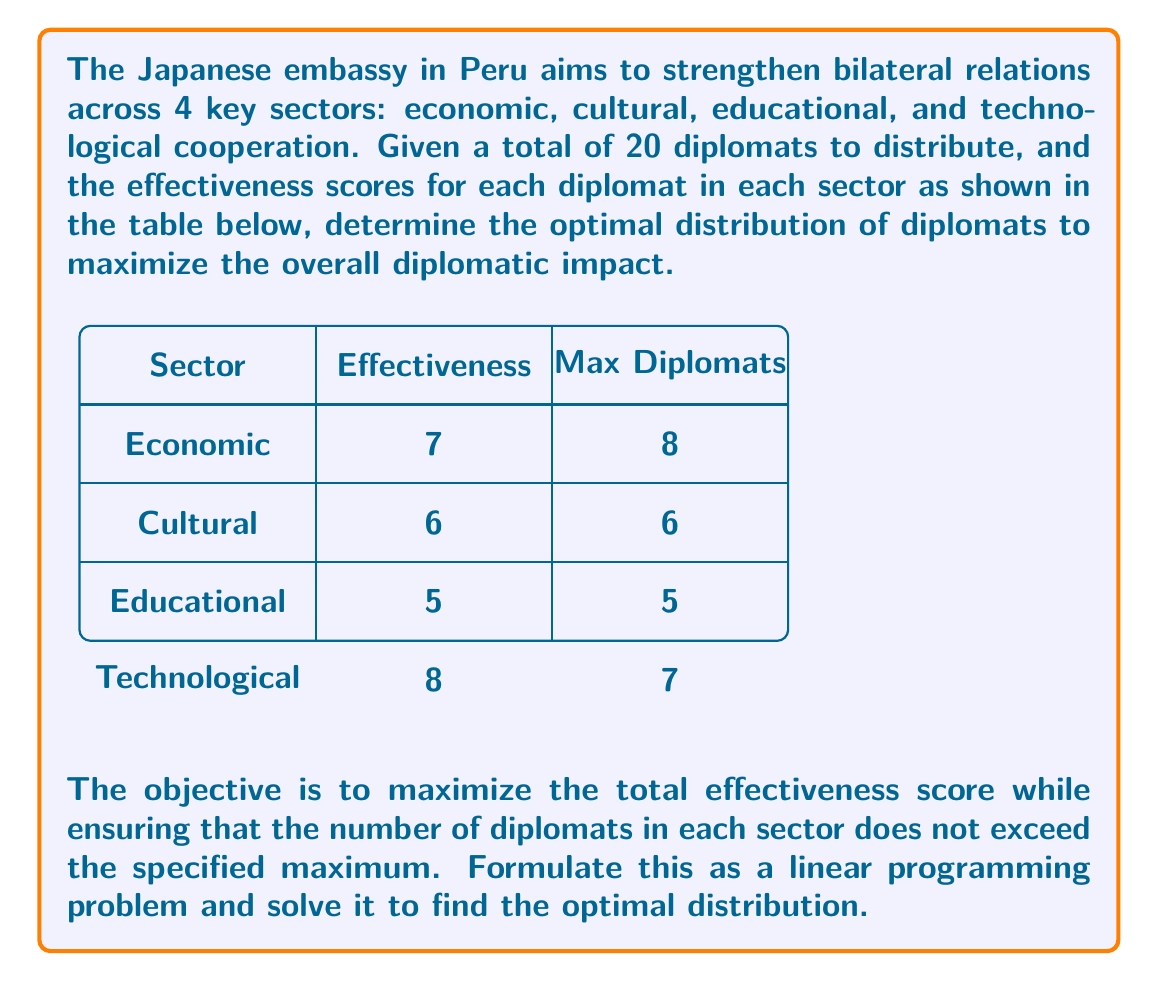What is the answer to this math problem? Let's approach this step-by-step:

1) Define variables:
   Let $x_1, x_2, x_3, x_4$ represent the number of diplomats assigned to economic, cultural, educational, and technological sectors respectively.

2) Objective function:
   Maximize $Z = 7x_1 + 6x_2 + 5x_3 + 8x_4$

3) Constraints:
   a) Total diplomats: $x_1 + x_2 + x_3 + x_4 \leq 20$
   b) Sector limits: $x_1 \leq 8, x_2 \leq 6, x_3 \leq 5, x_4 \leq 7$
   c) Non-negativity: $x_1, x_2, x_3, x_4 \geq 0$

4) This is a linear programming problem. We can solve it using the simplex method or a graphical method. In this case, we'll use a greedy approach due to the nature of the problem:

   - Start with the sector with the highest effectiveness (Technological: 8)
   - Assign the maximum allowed diplomats (7)
   - Move to the next highest effectiveness sector (Economic: 7)
   - Assign the remaining diplomats (13) up to the maximum allowed (8)
   - Continue this process

5) Distribution:
   Technological: 7 diplomats
   Economic: 8 diplomats
   Cultural: 5 diplomats (remaining diplomats)
   Educational: 0 diplomats

6) Check constraints:
   Total diplomats used: 7 + 8 + 5 + 0 = 20 (satisfies total constraint)
   All sector limits are respected

7) Calculate total effectiveness:
   $Z = 7(8) + 6(5) + 5(0) + 8(7) = 56 + 30 + 0 + 56 = 142$

Therefore, the optimal distribution is 8 diplomats in the economic sector, 5 in the cultural sector, 0 in the educational sector, and 7 in the technological sector, yielding a total effectiveness score of 142.
Answer: Economic: 8, Cultural: 5, Educational: 0, Technological: 7 